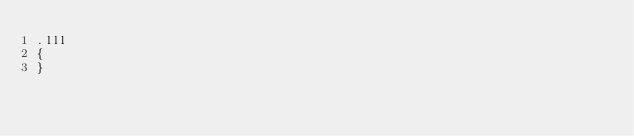Convert code to text. <code><loc_0><loc_0><loc_500><loc_500><_CSS_>.lll
{
}
</code> 